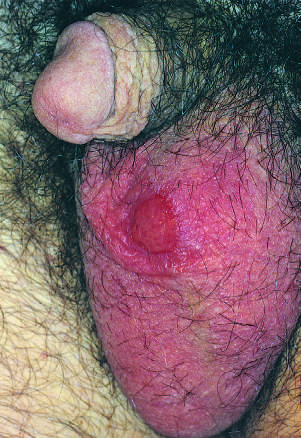re numerous islands of extramedullary hematopoiesis painless despite the presence of ulceration?
Answer the question using a single word or phrase. No 